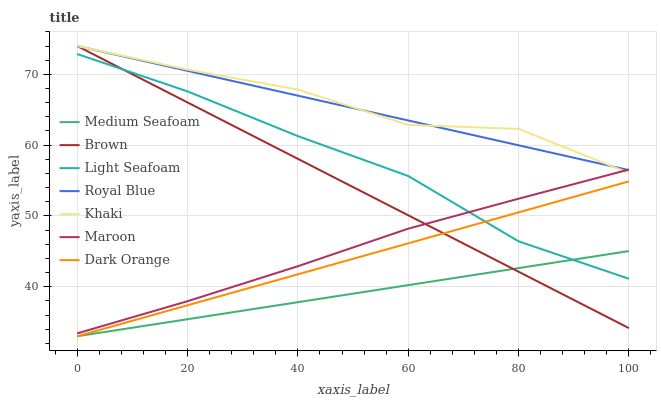Does Dark Orange have the minimum area under the curve?
Answer yes or no. No. Does Dark Orange have the maximum area under the curve?
Answer yes or no. No. Is Dark Orange the smoothest?
Answer yes or no. No. Is Dark Orange the roughest?
Answer yes or no. No. Does Khaki have the lowest value?
Answer yes or no. No. Does Dark Orange have the highest value?
Answer yes or no. No. Is Medium Seafoam less than Royal Blue?
Answer yes or no. Yes. Is Khaki greater than Dark Orange?
Answer yes or no. Yes. Does Medium Seafoam intersect Royal Blue?
Answer yes or no. No. 